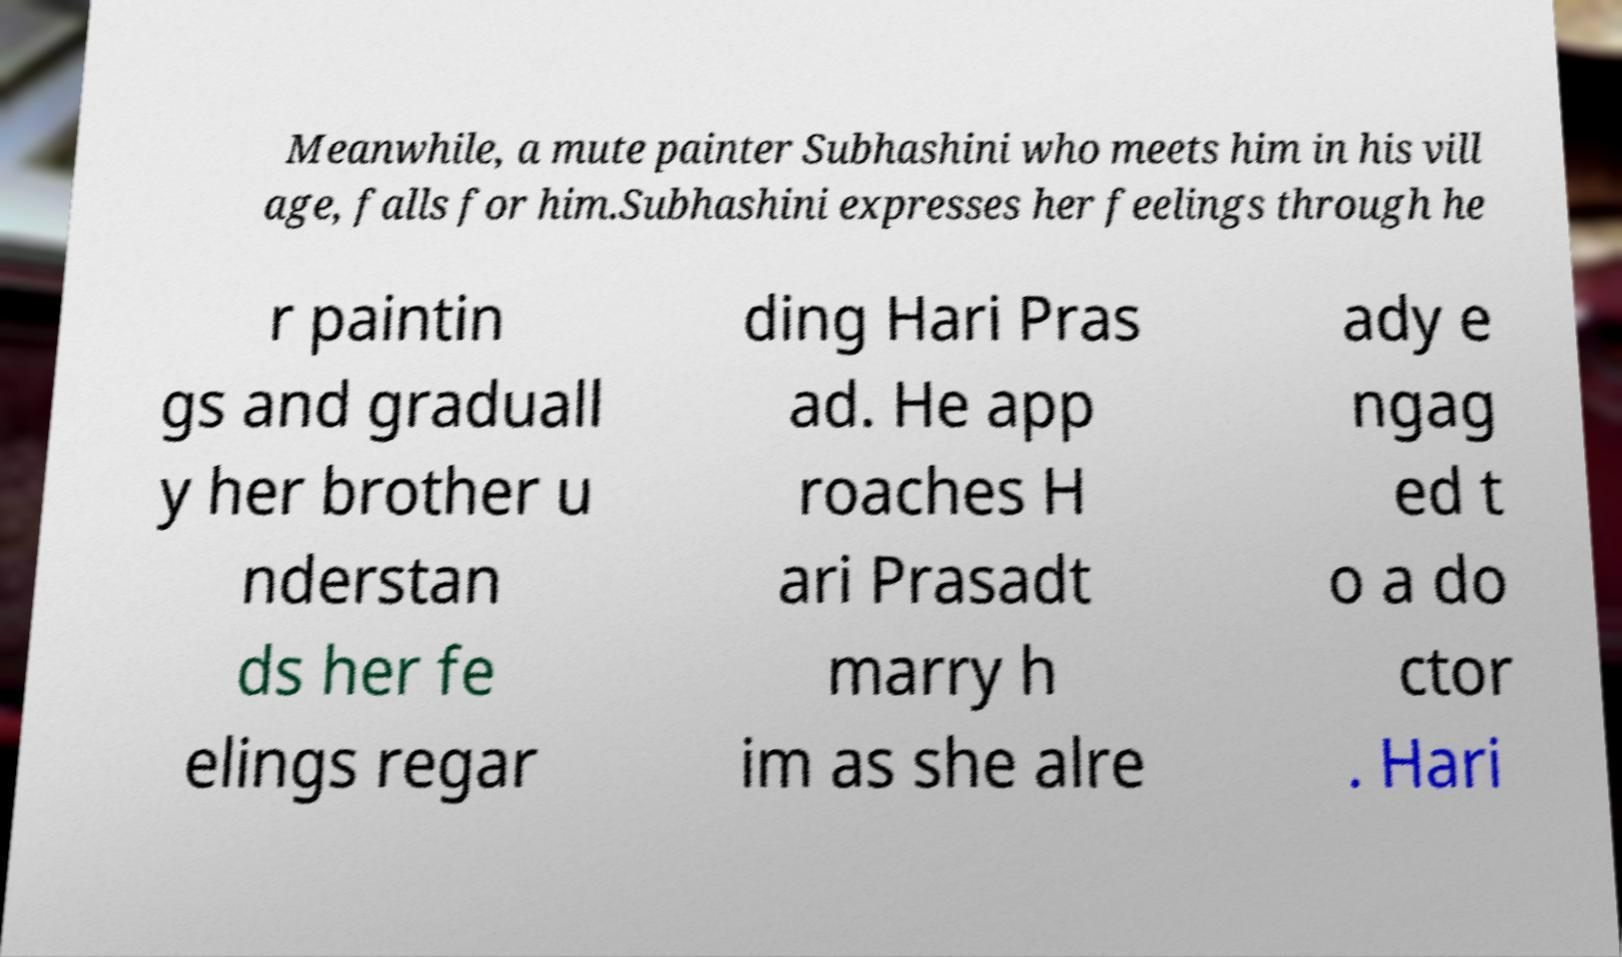Can you read and provide the text displayed in the image?This photo seems to have some interesting text. Can you extract and type it out for me? Meanwhile, a mute painter Subhashini who meets him in his vill age, falls for him.Subhashini expresses her feelings through he r paintin gs and graduall y her brother u nderstan ds her fe elings regar ding Hari Pras ad. He app roaches H ari Prasadt marry h im as she alre ady e ngag ed t o a do ctor . Hari 